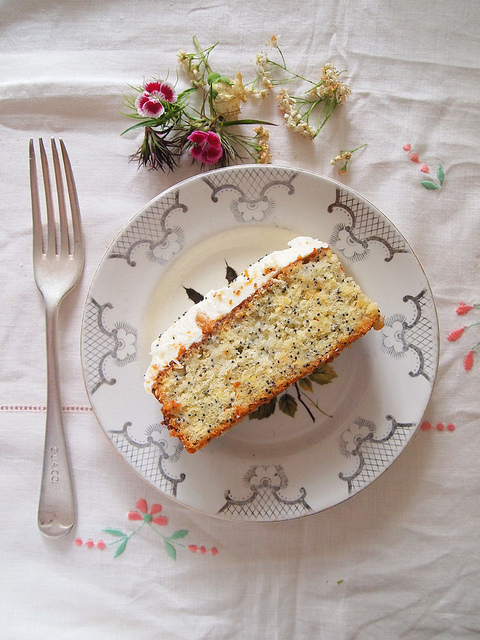What objects are present in the image? The image displays several objects including a decorative plate, a delectable piece of cake situated on the plate, a fork positioned to the left, an artfully arranged bouquet of flowers, and an elegantly patterned tablecloth. 